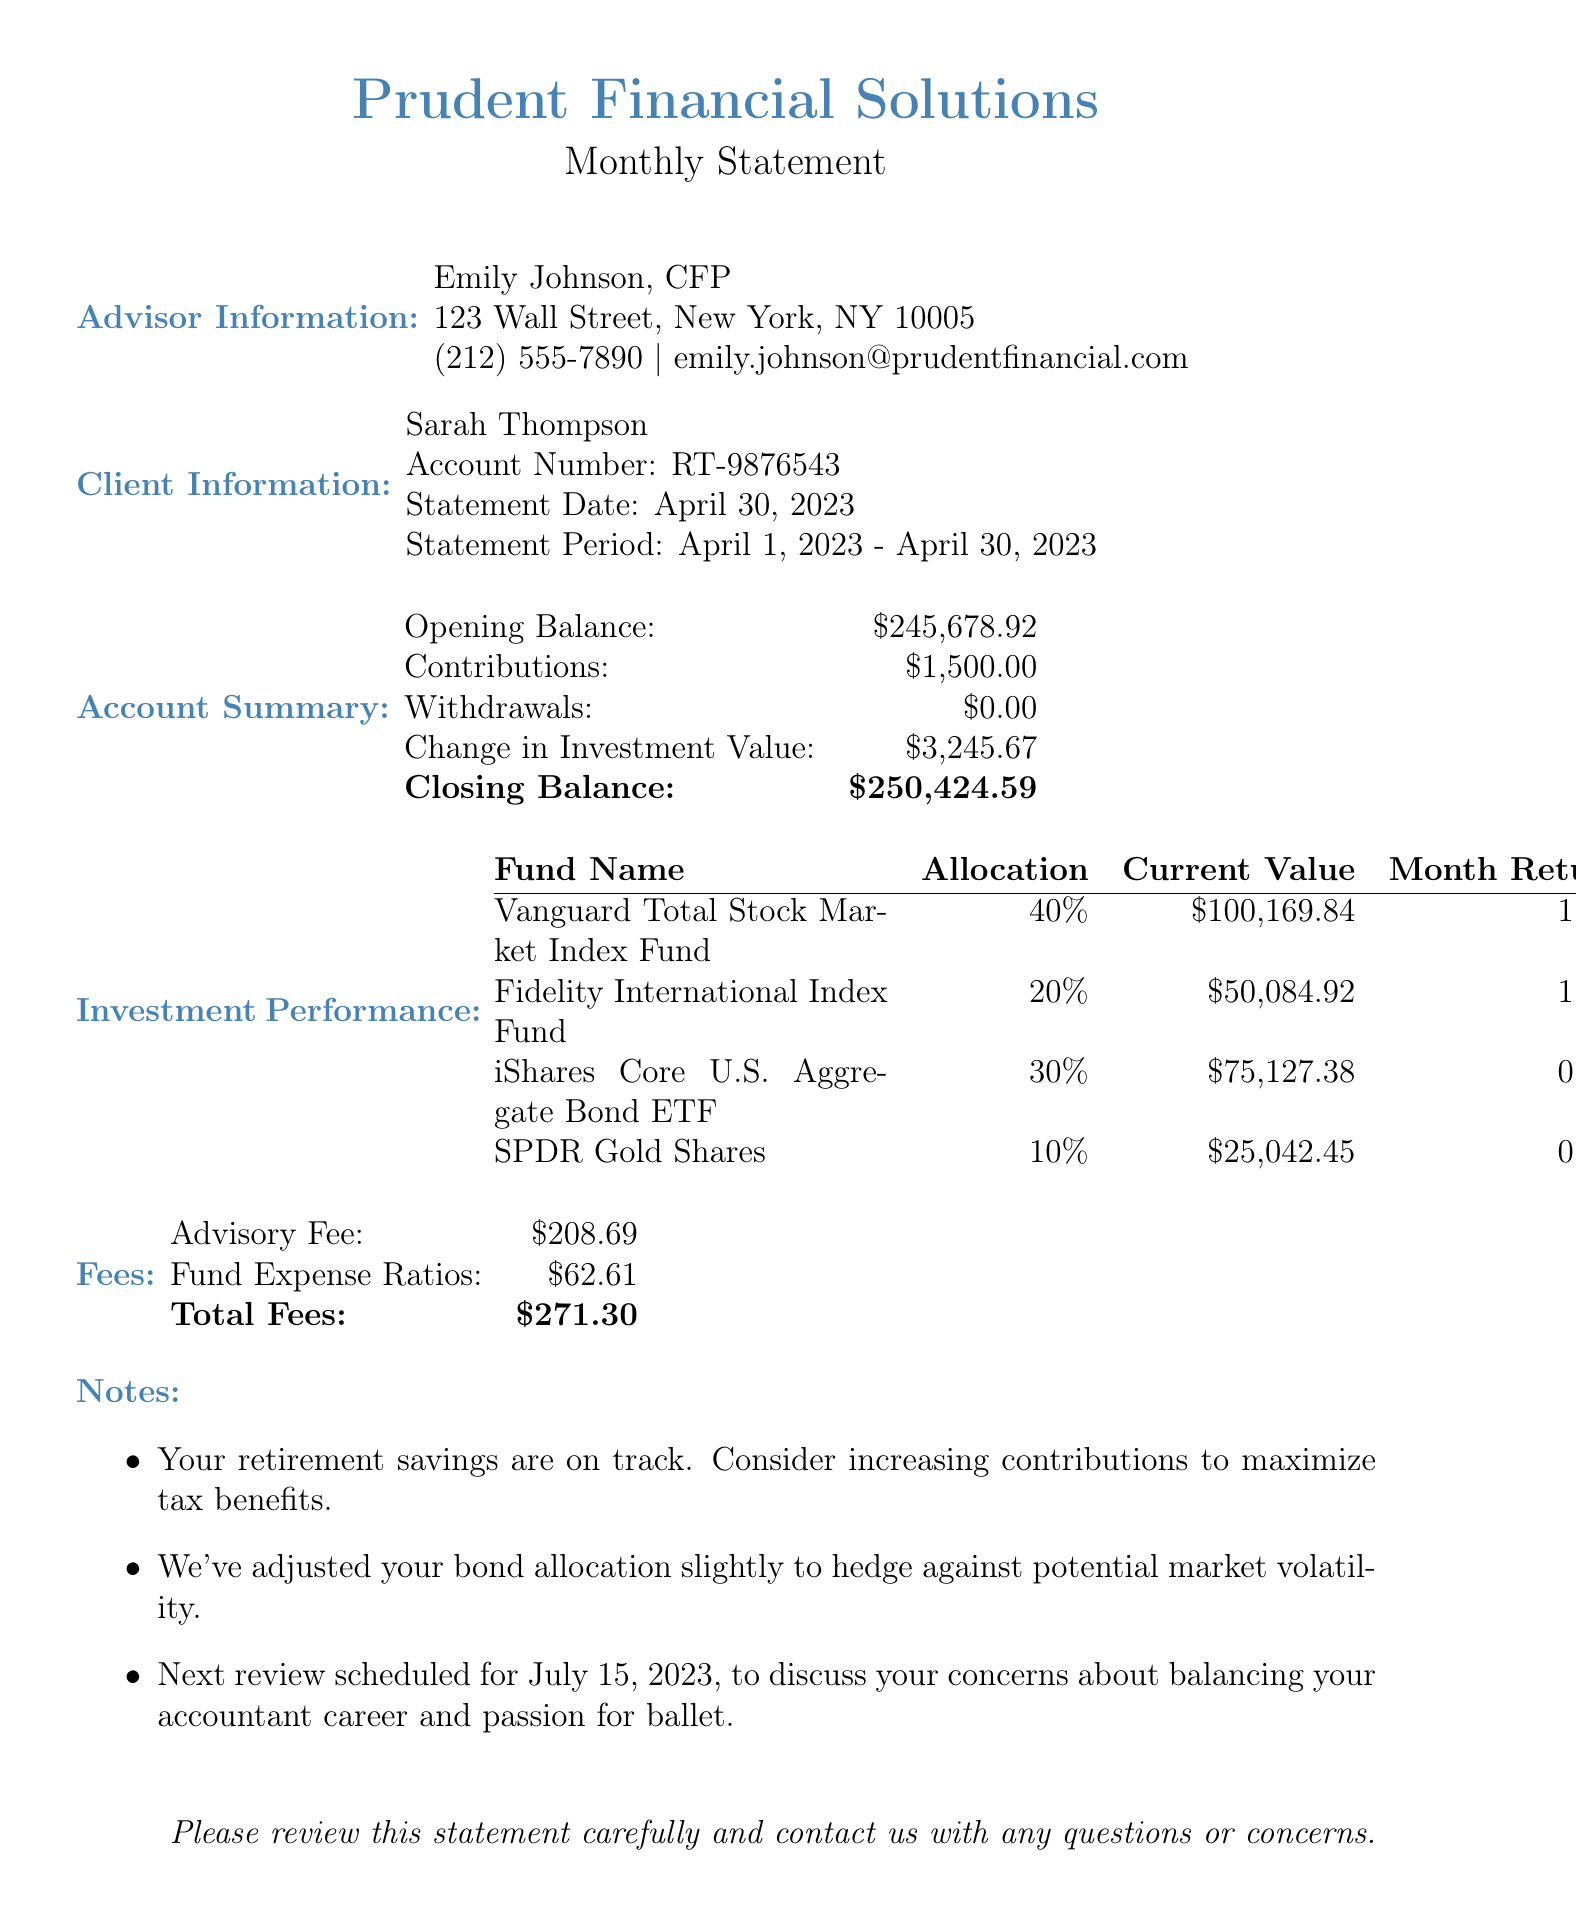What is the advisor's name? The advisor's name is listed at the top of the document under Advisor Information.
Answer: Emily Johnson, CFP What is the total fees charged for this month? The total fees are provided in the Fees section of the document which sums the advisory fee and fund expense ratios.
Answer: $271.30 What is the opening balance of the account? The opening balance is shown in the Account Summary section.
Answer: $245,678.92 What was the month return for the Vanguard Total Stock Market Index Fund? The month return for this fund is specified in the Investment Performance section of the document.
Answer: 1.8% How much did Sarah Thompson contribute this month? The Contributions amount is indicated in the Account Summary section of the document.
Answer: $1,500.00 What was the closing balance at the end of the statement period? The closing balance is highlighted in bold in the Account Summary.
Answer: $250,424.59 What percentage of the portfolio is allocated to the SPDR Gold Shares? The allocation percentage is found in the Investment Performance section of the document.
Answer: 10% When is the next review scheduled? The date for the next review is mentioned in the Notes section of the document.
Answer: July 15, 2023 What was the change in investment value for the statement period? This figure is reported in the Account Summary section.
Answer: $3,245.67 